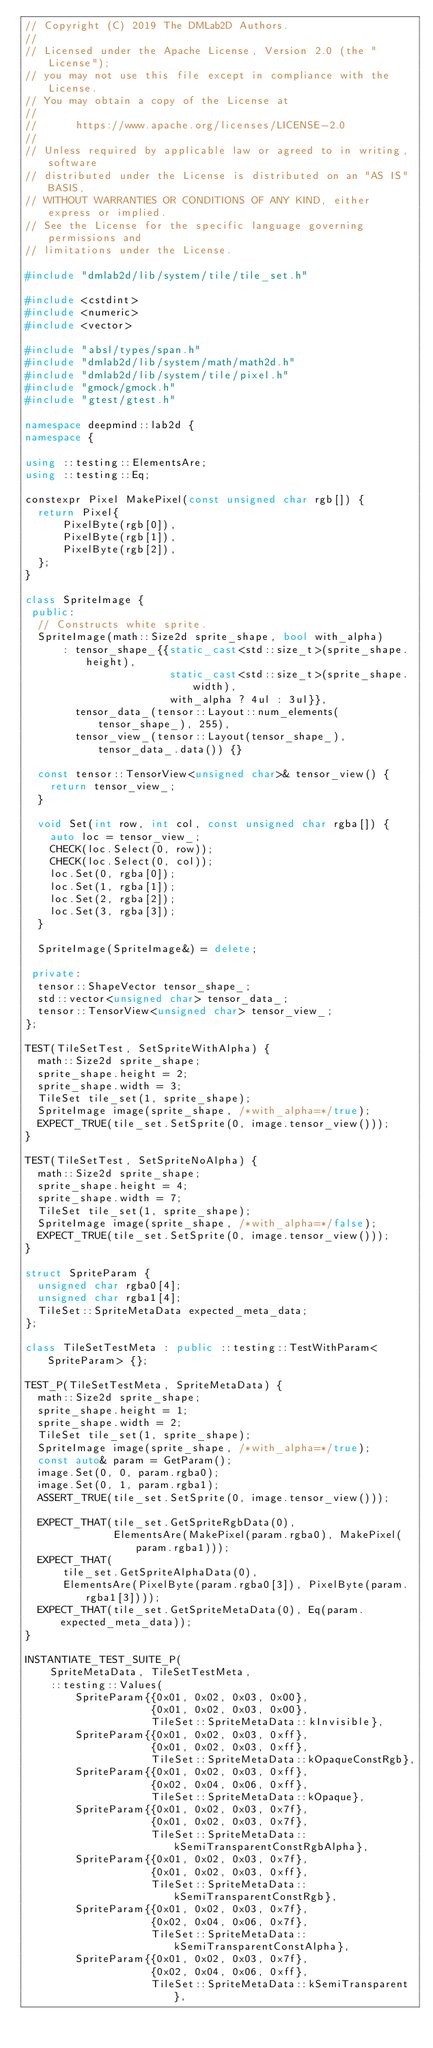Convert code to text. <code><loc_0><loc_0><loc_500><loc_500><_C++_>// Copyright (C) 2019 The DMLab2D Authors.
//
// Licensed under the Apache License, Version 2.0 (the "License");
// you may not use this file except in compliance with the License.
// You may obtain a copy of the License at
//
//      https://www.apache.org/licenses/LICENSE-2.0
//
// Unless required by applicable law or agreed to in writing, software
// distributed under the License is distributed on an "AS IS" BASIS,
// WITHOUT WARRANTIES OR CONDITIONS OF ANY KIND, either express or implied.
// See the License for the specific language governing permissions and
// limitations under the License.

#include "dmlab2d/lib/system/tile/tile_set.h"

#include <cstdint>
#include <numeric>
#include <vector>

#include "absl/types/span.h"
#include "dmlab2d/lib/system/math/math2d.h"
#include "dmlab2d/lib/system/tile/pixel.h"
#include "gmock/gmock.h"
#include "gtest/gtest.h"

namespace deepmind::lab2d {
namespace {

using ::testing::ElementsAre;
using ::testing::Eq;

constexpr Pixel MakePixel(const unsigned char rgb[]) {
  return Pixel{
      PixelByte(rgb[0]),
      PixelByte(rgb[1]),
      PixelByte(rgb[2]),
  };
}

class SpriteImage {
 public:
  // Constructs white sprite.
  SpriteImage(math::Size2d sprite_shape, bool with_alpha)
      : tensor_shape_{{static_cast<std::size_t>(sprite_shape.height),
                       static_cast<std::size_t>(sprite_shape.width),
                       with_alpha ? 4ul : 3ul}},
        tensor_data_(tensor::Layout::num_elements(tensor_shape_), 255),
        tensor_view_(tensor::Layout(tensor_shape_), tensor_data_.data()) {}

  const tensor::TensorView<unsigned char>& tensor_view() {
    return tensor_view_;
  }

  void Set(int row, int col, const unsigned char rgba[]) {
    auto loc = tensor_view_;
    CHECK(loc.Select(0, row));
    CHECK(loc.Select(0, col));
    loc.Set(0, rgba[0]);
    loc.Set(1, rgba[1]);
    loc.Set(2, rgba[2]);
    loc.Set(3, rgba[3]);
  }

  SpriteImage(SpriteImage&) = delete;

 private:
  tensor::ShapeVector tensor_shape_;
  std::vector<unsigned char> tensor_data_;
  tensor::TensorView<unsigned char> tensor_view_;
};

TEST(TileSetTest, SetSpriteWithAlpha) {
  math::Size2d sprite_shape;
  sprite_shape.height = 2;
  sprite_shape.width = 3;
  TileSet tile_set(1, sprite_shape);
  SpriteImage image(sprite_shape, /*with_alpha=*/true);
  EXPECT_TRUE(tile_set.SetSprite(0, image.tensor_view()));
}

TEST(TileSetTest, SetSpriteNoAlpha) {
  math::Size2d sprite_shape;
  sprite_shape.height = 4;
  sprite_shape.width = 7;
  TileSet tile_set(1, sprite_shape);
  SpriteImage image(sprite_shape, /*with_alpha=*/false);
  EXPECT_TRUE(tile_set.SetSprite(0, image.tensor_view()));
}

struct SpriteParam {
  unsigned char rgba0[4];
  unsigned char rgba1[4];
  TileSet::SpriteMetaData expected_meta_data;
};

class TileSetTestMeta : public ::testing::TestWithParam<SpriteParam> {};

TEST_P(TileSetTestMeta, SpriteMetaData) {
  math::Size2d sprite_shape;
  sprite_shape.height = 1;
  sprite_shape.width = 2;
  TileSet tile_set(1, sprite_shape);
  SpriteImage image(sprite_shape, /*with_alpha=*/true);
  const auto& param = GetParam();
  image.Set(0, 0, param.rgba0);
  image.Set(0, 1, param.rgba1);
  ASSERT_TRUE(tile_set.SetSprite(0, image.tensor_view()));

  EXPECT_THAT(tile_set.GetSpriteRgbData(0),
              ElementsAre(MakePixel(param.rgba0), MakePixel(param.rgba1)));
  EXPECT_THAT(
      tile_set.GetSpriteAlphaData(0),
      ElementsAre(PixelByte(param.rgba0[3]), PixelByte(param.rgba1[3])));
  EXPECT_THAT(tile_set.GetSpriteMetaData(0), Eq(param.expected_meta_data));
}

INSTANTIATE_TEST_SUITE_P(
    SpriteMetaData, TileSetTestMeta,
    ::testing::Values(
        SpriteParam{{0x01, 0x02, 0x03, 0x00},
                    {0x01, 0x02, 0x03, 0x00},
                    TileSet::SpriteMetaData::kInvisible},
        SpriteParam{{0x01, 0x02, 0x03, 0xff},
                    {0x01, 0x02, 0x03, 0xff},
                    TileSet::SpriteMetaData::kOpaqueConstRgb},
        SpriteParam{{0x01, 0x02, 0x03, 0xff},
                    {0x02, 0x04, 0x06, 0xff},
                    TileSet::SpriteMetaData::kOpaque},
        SpriteParam{{0x01, 0x02, 0x03, 0x7f},
                    {0x01, 0x02, 0x03, 0x7f},
                    TileSet::SpriteMetaData::kSemiTransparentConstRgbAlpha},
        SpriteParam{{0x01, 0x02, 0x03, 0x7f},
                    {0x01, 0x02, 0x03, 0xff},
                    TileSet::SpriteMetaData::kSemiTransparentConstRgb},
        SpriteParam{{0x01, 0x02, 0x03, 0x7f},
                    {0x02, 0x04, 0x06, 0x7f},
                    TileSet::SpriteMetaData::kSemiTransparentConstAlpha},
        SpriteParam{{0x01, 0x02, 0x03, 0x7f},
                    {0x02, 0x04, 0x06, 0xff},
                    TileSet::SpriteMetaData::kSemiTransparent},</code> 